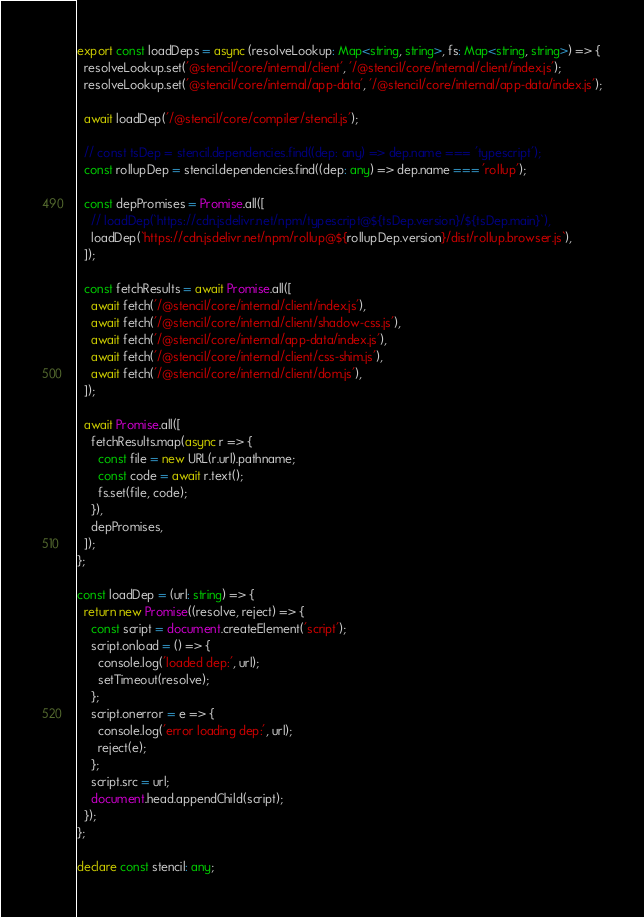<code> <loc_0><loc_0><loc_500><loc_500><_TypeScript_>export const loadDeps = async (resolveLookup: Map<string, string>, fs: Map<string, string>) => {
  resolveLookup.set('@stencil/core/internal/client', '/@stencil/core/internal/client/index.js');
  resolveLookup.set('@stencil/core/internal/app-data', '/@stencil/core/internal/app-data/index.js');

  await loadDep('/@stencil/core/compiler/stencil.js');

  // const tsDep = stencil.dependencies.find((dep: any) => dep.name === 'typescript');
  const rollupDep = stencil.dependencies.find((dep: any) => dep.name === 'rollup');

  const depPromises = Promise.all([
    // loadDep(`https://cdn.jsdelivr.net/npm/typescript@${tsDep.version}/${tsDep.main}`),
    loadDep(`https://cdn.jsdelivr.net/npm/rollup@${rollupDep.version}/dist/rollup.browser.js`),
  ]);

  const fetchResults = await Promise.all([
    await fetch('/@stencil/core/internal/client/index.js'),
    await fetch('/@stencil/core/internal/client/shadow-css.js'),
    await fetch('/@stencil/core/internal/app-data/index.js'),
    await fetch('/@stencil/core/internal/client/css-shim.js'),
    await fetch('/@stencil/core/internal/client/dom.js'),
  ]);

  await Promise.all([
    fetchResults.map(async r => {
      const file = new URL(r.url).pathname;
      const code = await r.text();
      fs.set(file, code);
    }),
    depPromises,
  ]);
};

const loadDep = (url: string) => {
  return new Promise((resolve, reject) => {
    const script = document.createElement('script');
    script.onload = () => {
      console.log('loaded dep:', url);
      setTimeout(resolve);
    };
    script.onerror = e => {
      console.log('error loading dep:', url);
      reject(e);
    };
    script.src = url;
    document.head.appendChild(script);
  });
};

declare const stencil: any;
</code> 